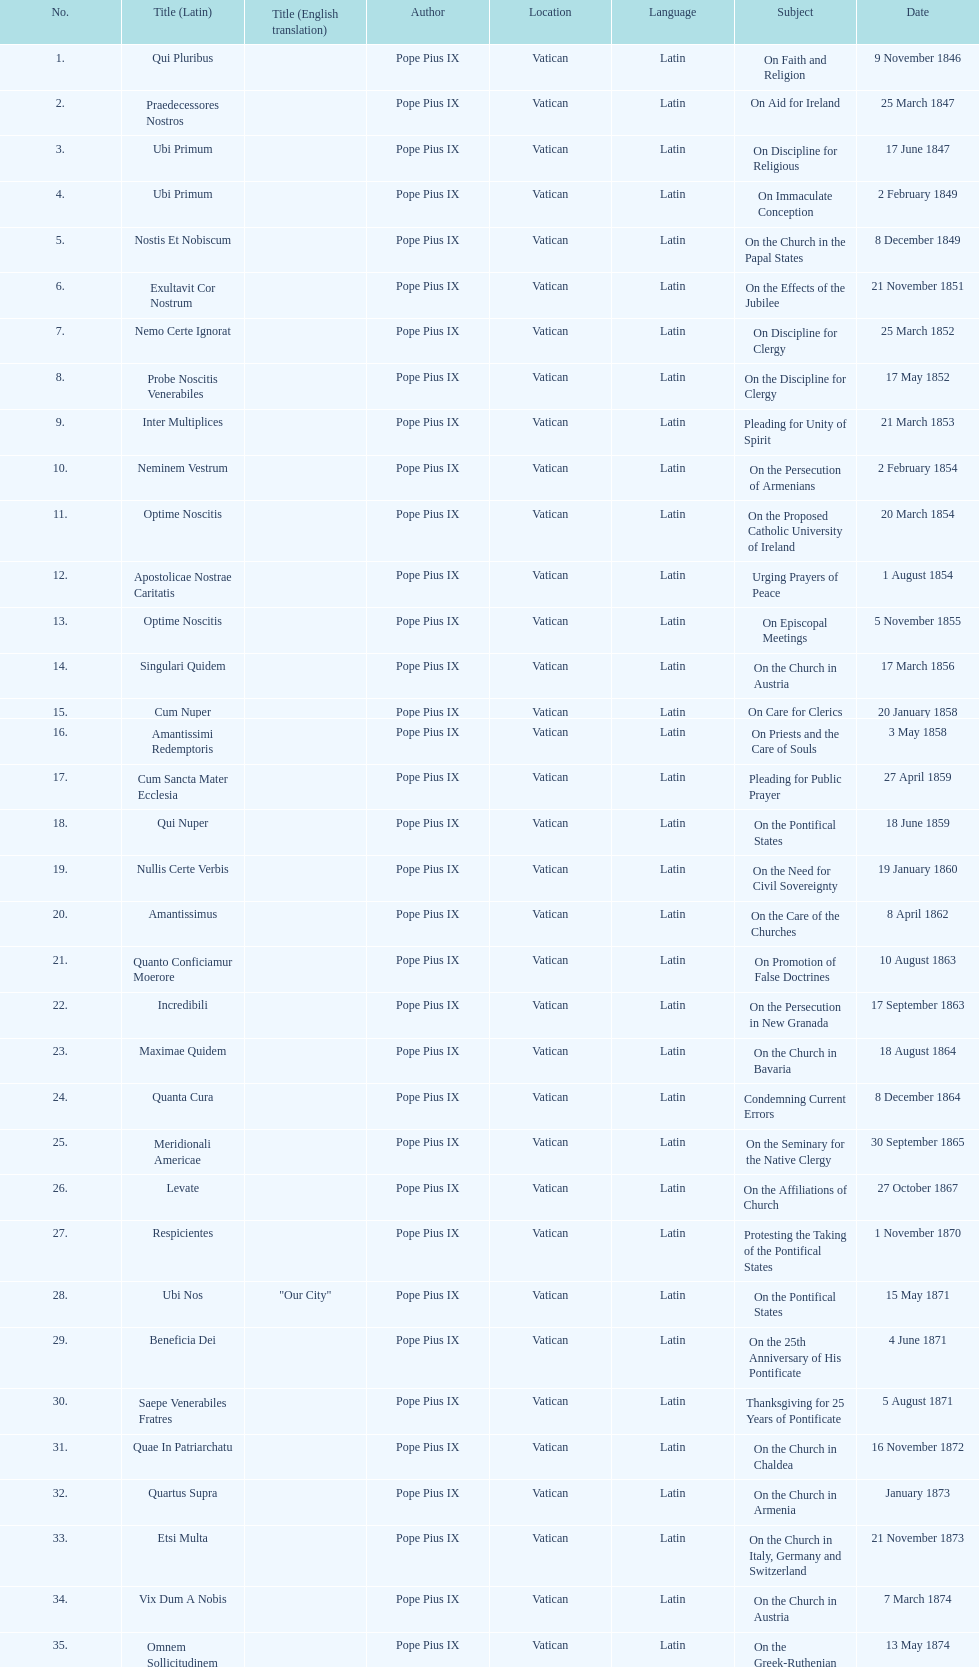How often was an encyclical sent in january? 3. 